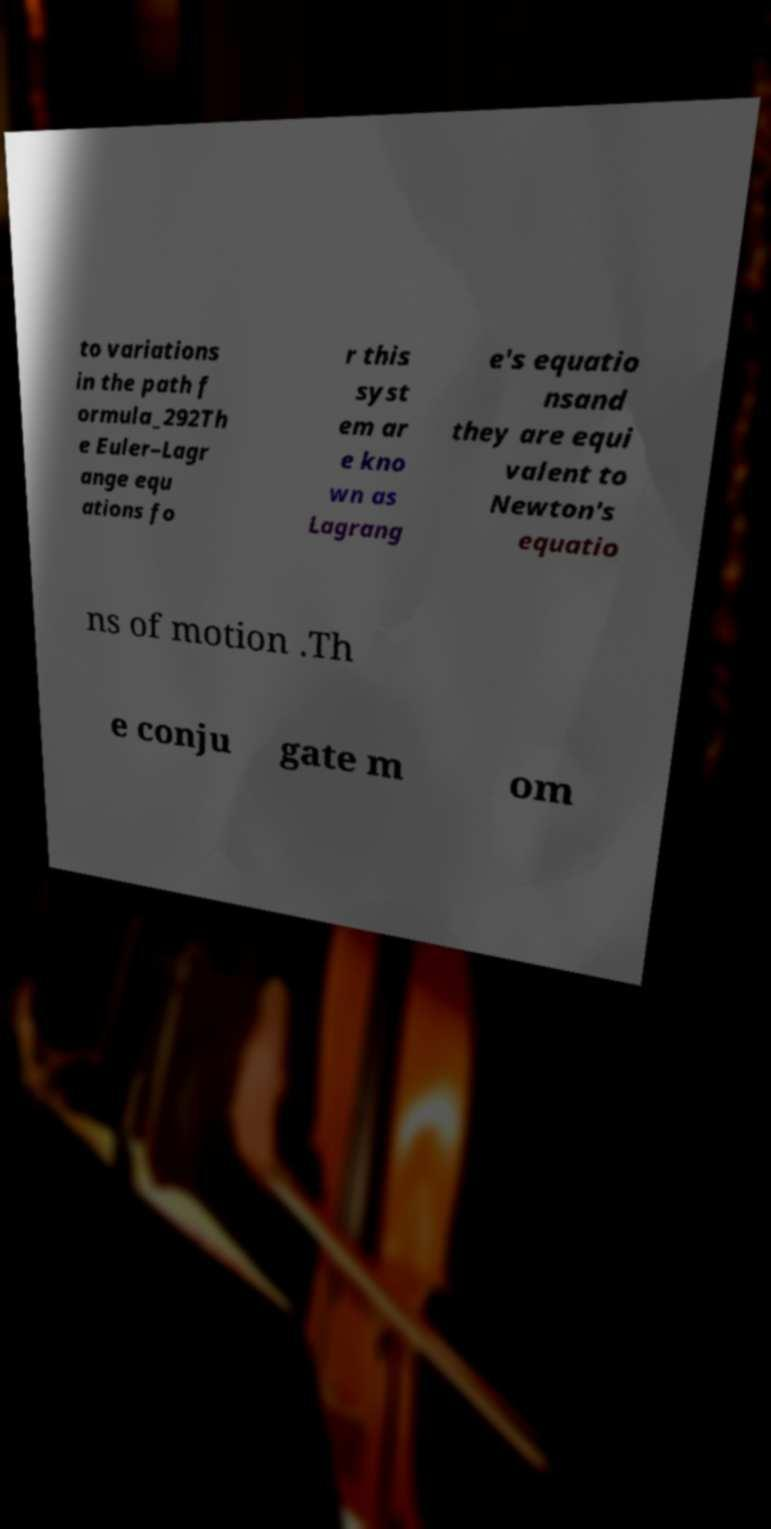Could you extract and type out the text from this image? to variations in the path f ormula_292Th e Euler–Lagr ange equ ations fo r this syst em ar e kno wn as Lagrang e's equatio nsand they are equi valent to Newton's equatio ns of motion .Th e conju gate m om 